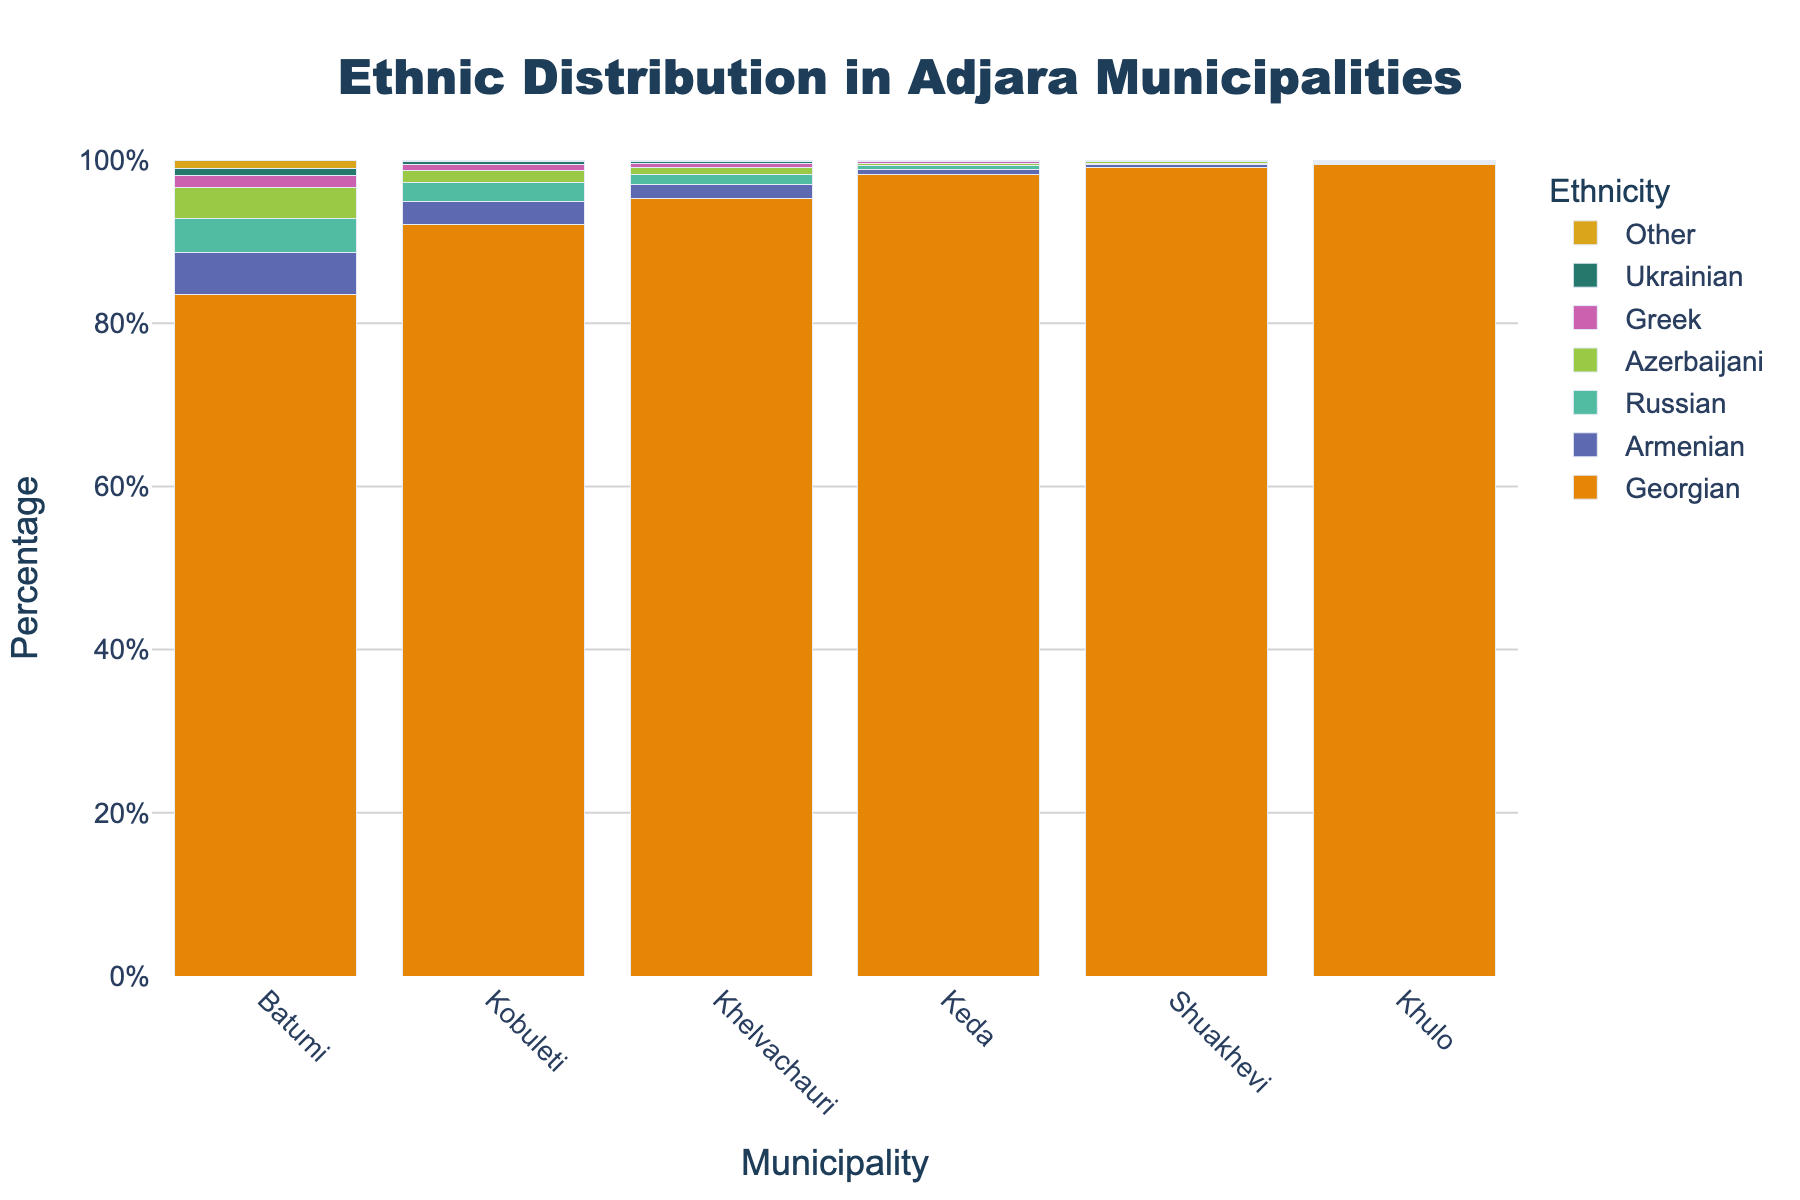Which municipality has the highest percentage of Georgians? By examining the bar traces for Georgians in each municipality, the tallest bar indicates the highest percentage. Khulo has the highest percentage for Georgians.
Answer: Khulo What is the range of the percentage of Armenians across all municipalities? Identify the maximum and minimum values for Armenians and then calculate the difference. The highest percentage is in Batumi (5.2%) and the lowest is in Khulo (0.2%). The range is 5.2% - 0.2% = 5.0%.
Answer: 5.0% Which two ethnicities have percentages below 1% in all municipalities? Check the height of each bar for all ethnicities in all municipalities. Ukrainian and Other categories consistently have percentages below 1%.
Answer: Ukrainian, Other How many municipalities have more than 90% Georgian population? Count the number of bars for Georgians that exceed the 90% mark across all municipalities. Keda, Khelvachauri, Kobuleti, Shuakhevi, and Khulo have more than 90% Georgians.
Answer: 5 What is the combined percentage of Russians in Batumi and Kobuleti? Add the percentages of Russians in Batumi (4.1%) and Kobuleti (2.3%) to get the combined total. 4.1% + 2.3% = 6.4%.
Answer: 6.4% Which municipality has the smallest diversity (i.e., the largest percentage of a single ethnicity)? Compare the highest single ethnicity percentage across each municipality. Khulo has the highest percentage of Georgians (99.4%), indicating the smallest diversity.
Answer: Khulo Is there any ethnicity that is not present in any municipality? Look for any ethnicity bars that are missing or have 0% indicated. The Ukrainian percentage is 0.0% in Shuakhevi and Khulo, but all ethnicities are present in at least one municipality. There is no ethnicity that is completely absent.
Answer: No How does the percentage of Azerbaijani differ between Batumi and Keda? Compare the percentages of Azerbaijanis in Batumi (3.8%) and Keda (0.3%). The difference is 3.8% - 0.3% = 3.5%.
Answer: 3.5% What's the average percentage of Greeks across all municipalities? Calculate the sum of percentages for Greeks and divide by the number of municipalities. (1.5% + 0.7% + 0.5% + 0.2% + 0.1% + 0.1%) / 6 = 3.1% / 6 ≈ 0.52%.
Answer: 0.52% What is the total percentage of ethnic minorities in Shuakhevi? Sum the percentages of all non-Georgian ethnicities in Shuakhevi. 0.3% (Armenian) + 0.2% (Russian) + 0.2% (Azerbaijani) + 0.1% (Greek) + 0.0% (Ukrainian) + 0.1% (Other) = 0.9%.
Answer: 0.9% 